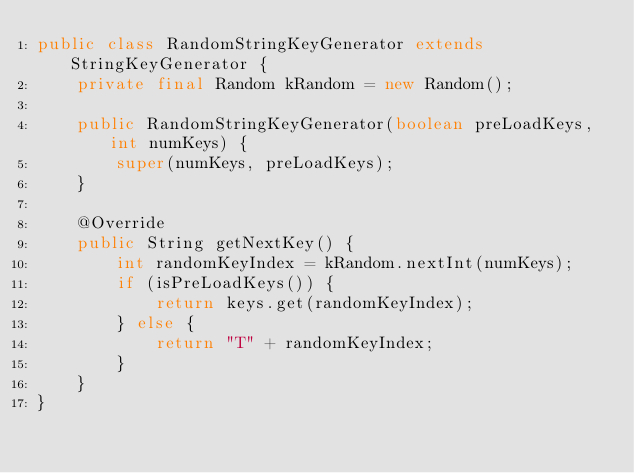<code> <loc_0><loc_0><loc_500><loc_500><_Java_>public class RandomStringKeyGenerator extends StringKeyGenerator {
    private final Random kRandom = new Random();

    public RandomStringKeyGenerator(boolean preLoadKeys, int numKeys) {
        super(numKeys, preLoadKeys);
    }

    @Override
    public String getNextKey() {
        int randomKeyIndex = kRandom.nextInt(numKeys);
        if (isPreLoadKeys()) {
            return keys.get(randomKeyIndex);
        } else {
            return "T" + randomKeyIndex;
        }
    }
}
</code> 